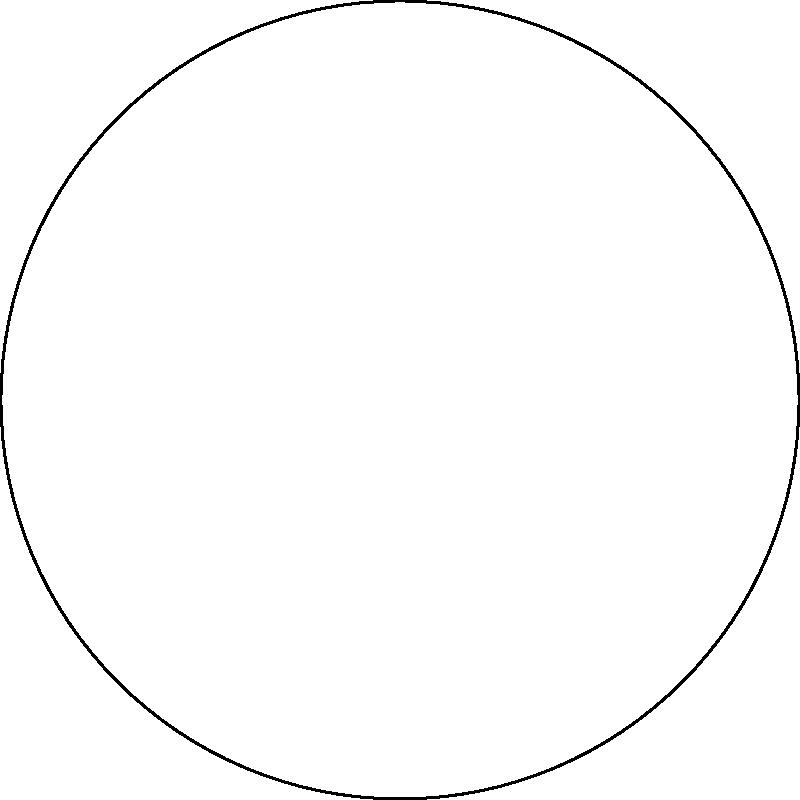As a diplomat navigating a neutral zone between two opposing territories, you need to plot the safest route from the start point in Territory A to the end point in Territory B. Which path through the neutral zone would be most appropriate to maintain neutrality and minimize potential conflicts? To determine the safest route while maintaining neutrality, we need to consider the following steps:

1. Identify the territories: The map shows Territory A (light blue) and Territory B (light red).

2. Locate the neutral zone: The area between the two territories (light green) represents the neutral zone.

3. Identify start and end points: The start point is in Territory A, and the end point is in Territory B.

4. Consider diplomatic implications:
   a. Avoiding direct paths through territories to prevent appearing biased.
   b. Maximizing time in the neutral zone to demonstrate impartiality.
   c. Maintaining equal distance from both territories when possible.

5. Analyze the optimal path:
   a. The path begins at the start point in Territory A.
   b. It quickly enters the neutral zone.
   c. The path curves through the center of the neutral zone, maintaining maximum distance from both territories.
   d. It ends at the designated point in Territory B.

6. Evaluate alternatives:
   a. A straight line would be shorter but could be perceived as favoring one side.
   b. Hugging the border of either territory could be seen as biased.

The optimal path (shown as a blue dashed line) provides the best balance of neutrality and efficiency by maximizing time in the neutral zone and maintaining equal distance from both territories when possible.
Answer: Curved path through the center of the neutral zone 